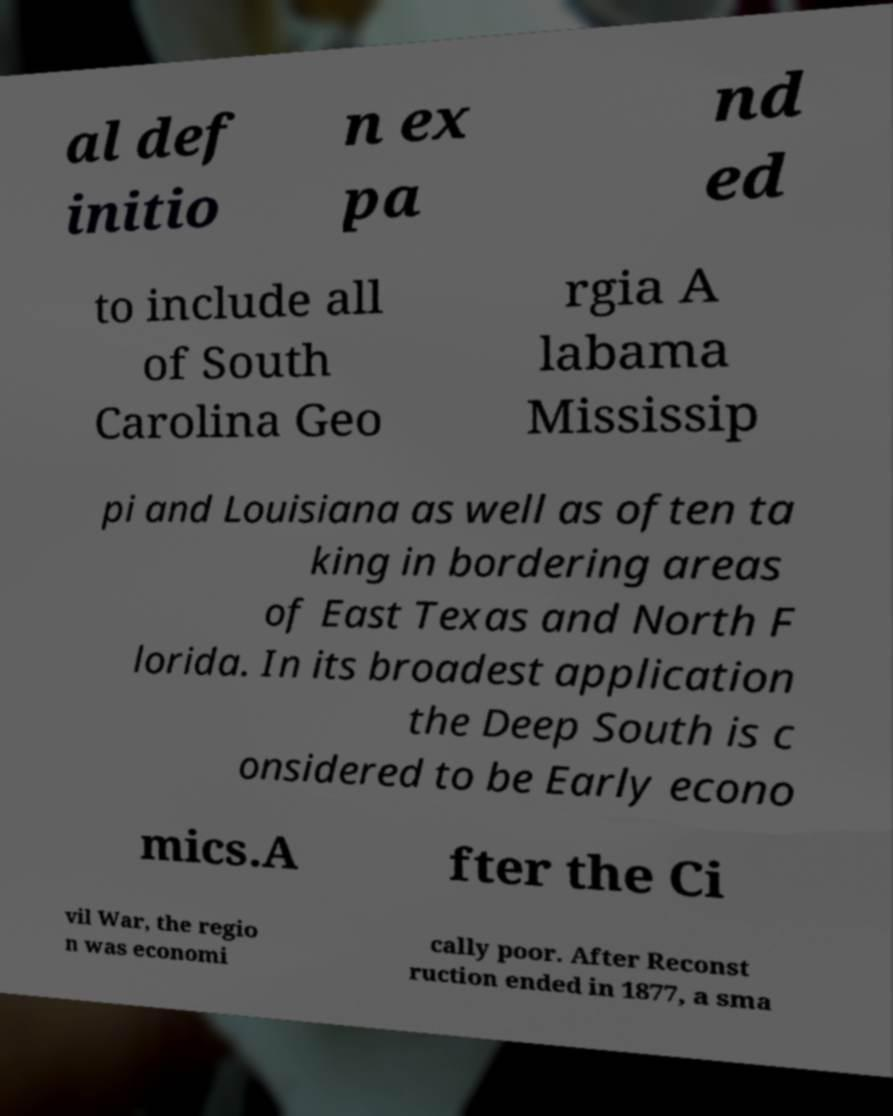Please identify and transcribe the text found in this image. al def initio n ex pa nd ed to include all of South Carolina Geo rgia A labama Mississip pi and Louisiana as well as often ta king in bordering areas of East Texas and North F lorida. In its broadest application the Deep South is c onsidered to be Early econo mics.A fter the Ci vil War, the regio n was economi cally poor. After Reconst ruction ended in 1877, a sma 